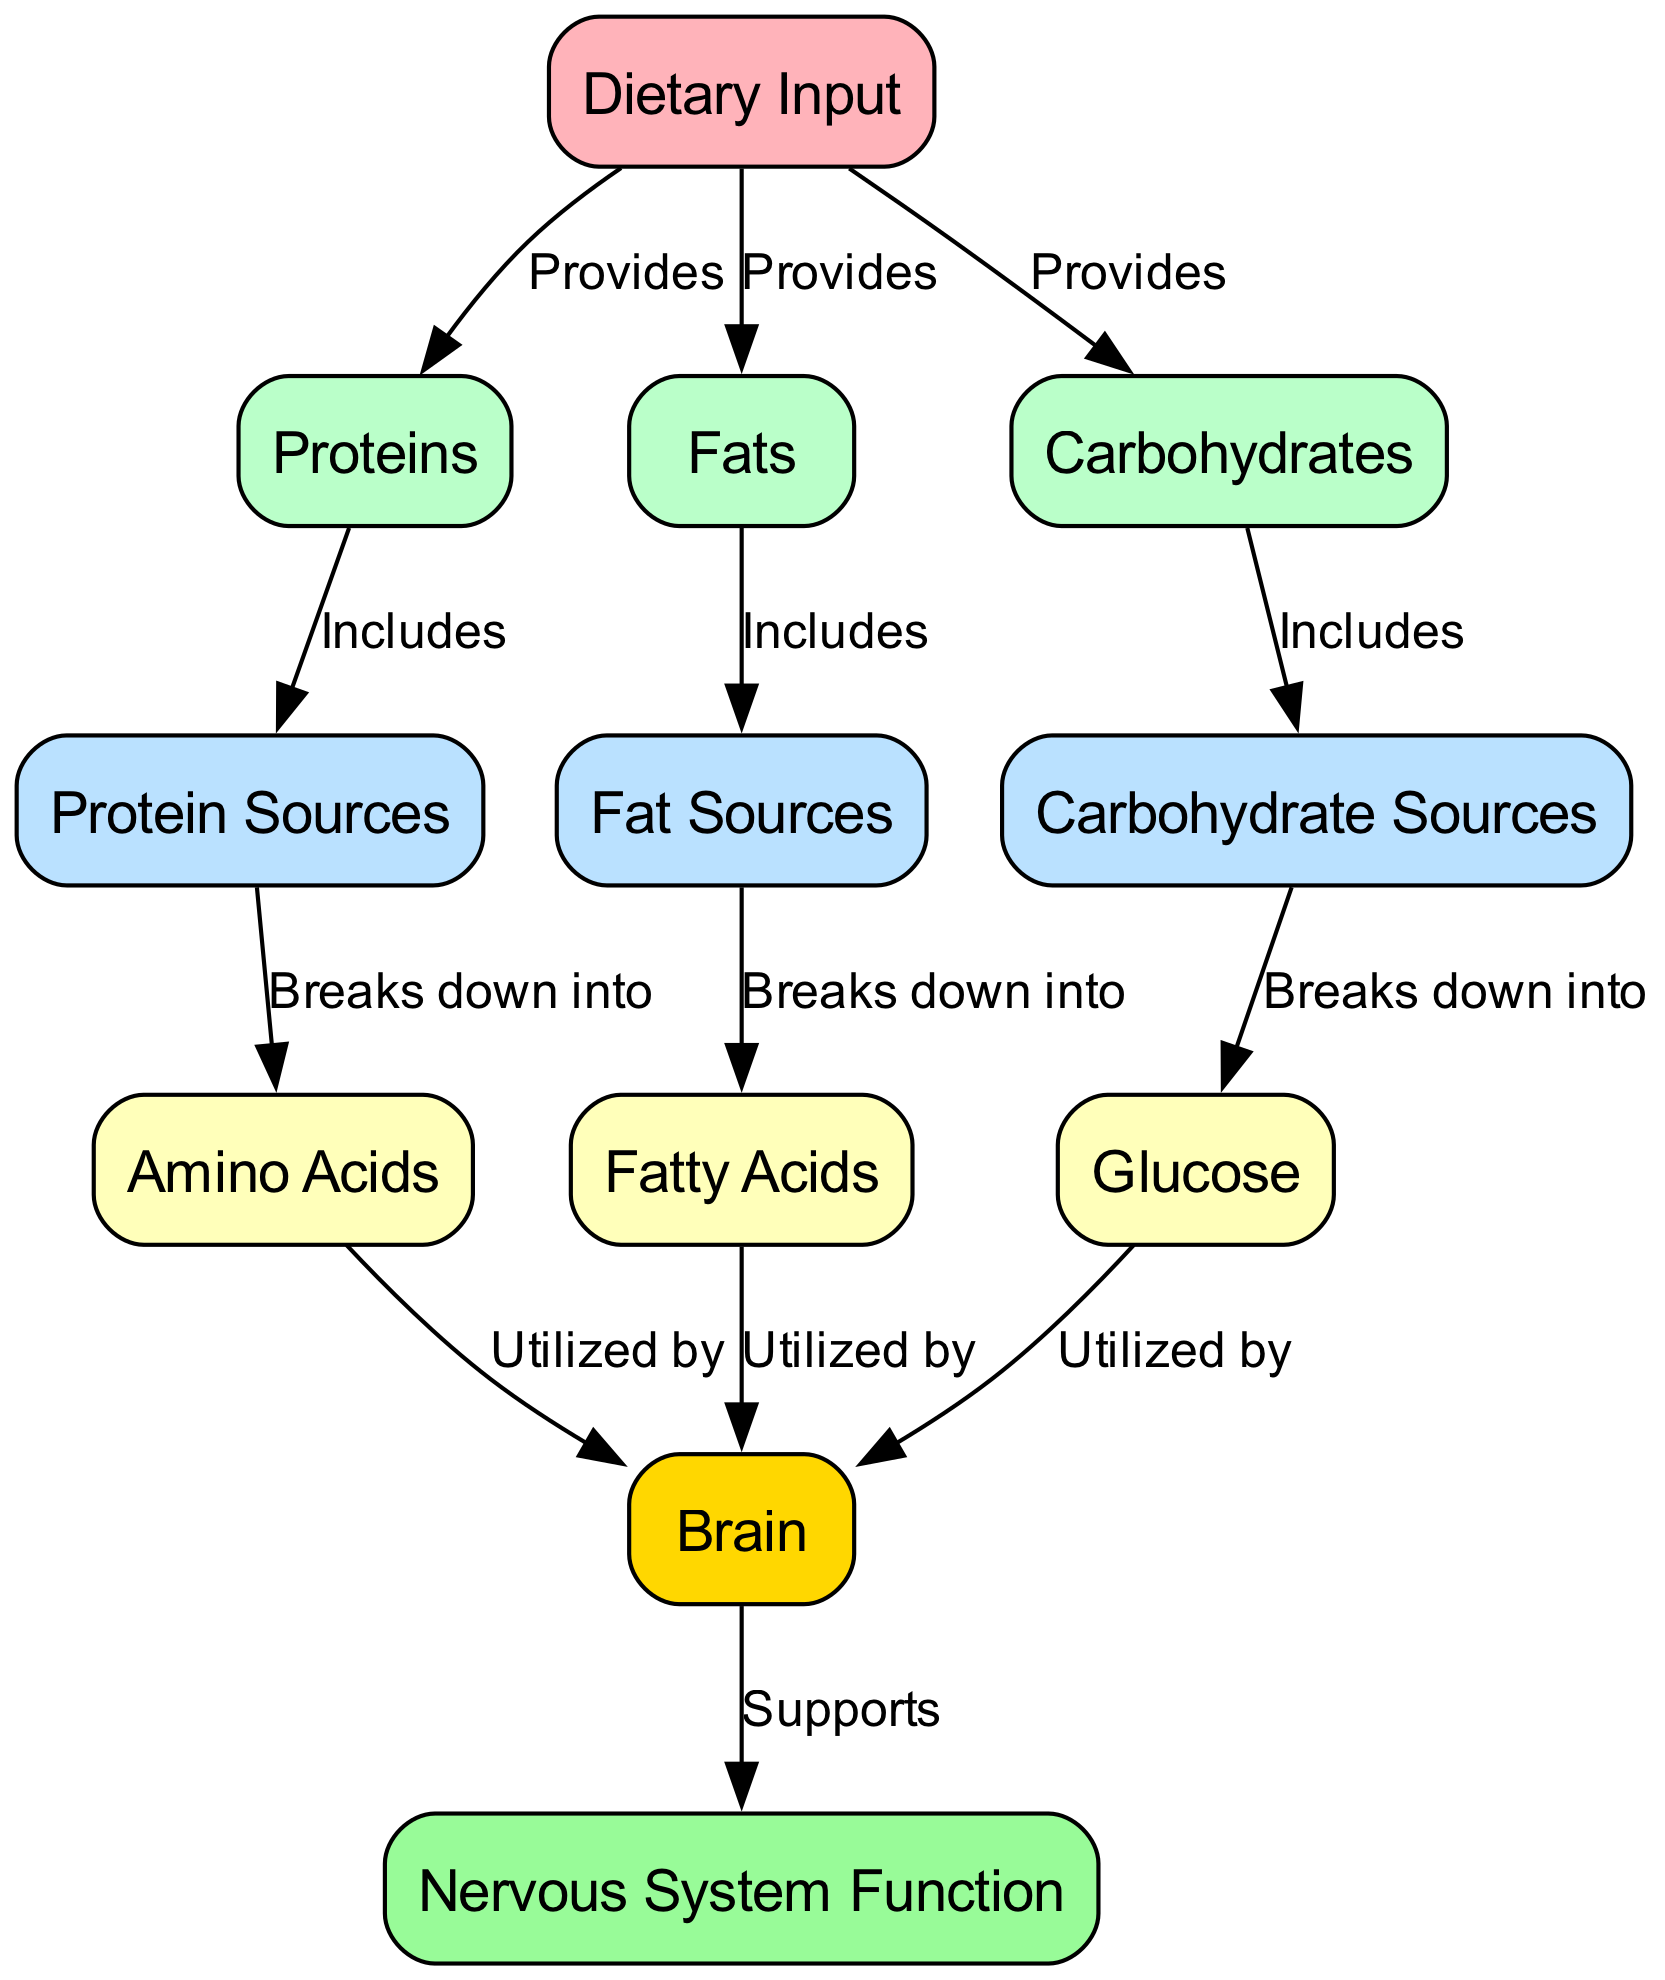What are the three main nutrient categories provided by dietary input? The diagram indicates that dietary input provides proteins, fats, and carbohydrates. These categories are directly linked to the dietary input node, showcasing their primary contribution to nutrient intake.
Answer: proteins, fats, carbohydrates Which node breaks down into amino acids? The diagram shows that protein sources break down into amino acids. This connection is represented by the arrow from protein sources to amino acids, indicating the process of breakdown.
Answer: protein sources How many sources are defined in the diagram? The diagram clearly outlines three sources: protein sources, fat sources, and carbohydrate sources. Counting these nodes connected to nutrient categories yields a total of three sources.
Answer: 3 What does the brain utilize from glucose? According to the diagram, glucose is directly utilized by the brain. This relationship is expressed through the edge that connects glucose to the brain, emphasizing its role in brain function.
Answer: glucose Which nutrient category includes fat sources? The diagram indicates that the fats category includes fat sources. This is shown by the relationship between the nutrient category of fats and the fat sources node within the food chain visualization.
Answer: fats What does the brain support? The diagram demonstrates that the brain supports nervous system function. This relationship is depicted by the edge connecting the brain node to the nervous system function node, illustrating its critical role.
Answer: nervous system function What is the last step in the nutrient flow towards nervous system function? The last step in the nutrient flow involves the brain supporting nervous system function. This is depicted by the final arrow leading from the brain node to the nervous system function node in the diagram.
Answer: brain How are fatty acids sourced? The diagram shows that fatty acids are sourced from fat sources. This relationship is indicated by the edge that connects fat sources to fatty acids, outlining their origin.
Answer: fat sources 